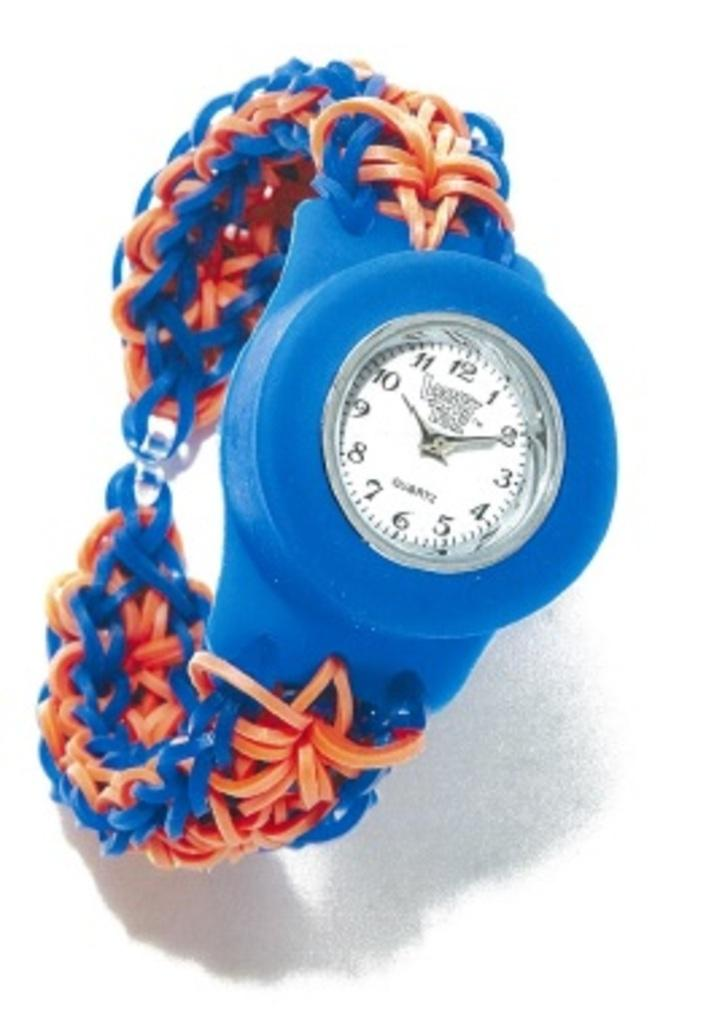<image>
Offer a succinct explanation of the picture presented. A wrist watch with the time of 10:10 is displayed 